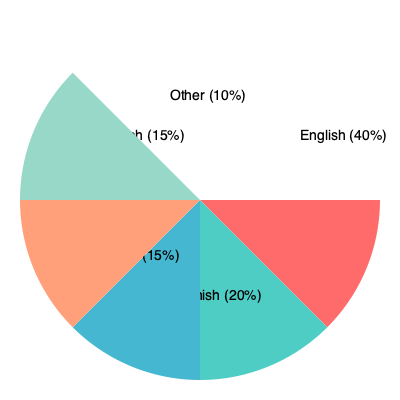Based on the pie chart depicting language use in a multilingual community, what sociolinguistic phenomenon might explain the dominance of English, and how could this impact social stratification? To answer this question, let's analyze the pie chart and consider sociolinguistic concepts:

1. Language distribution:
   - English: 40%
   - Spanish: 20%
   - Mandarin: 15%
   - French: 15%
   - Other: 10%

2. English dominance:
   English clearly dominates at 40%, which is twice the percentage of the next most spoken language (Spanish at 20%).

3. Sociolinguistic phenomenon:
   This distribution suggests linguistic hegemony, where English has become the dominant language in this multilingual community.

4. Factors contributing to linguistic hegemony:
   a) Historical factors (e.g., colonialism, immigration patterns)
   b) Economic factors (e.g., global business language)
   c) Cultural factors (e.g., media influence, education system)

5. Impact on social stratification:
   a) Access to opportunities: Those proficient in English may have better access to education and job opportunities.
   b) Social mobility: English proficiency could become a factor in upward social mobility.
   c) Cultural capital: English skills may be viewed as valuable cultural capital.
   d) Power dynamics: English speakers might have more influence in social and political spheres.

6. Potential consequences:
   a) Language shift: Minority languages might be at risk of decline.
   b) Linguistic inequality: Non-English speakers may face social and economic disadvantages.
   c) Identity negotiation: Individuals may struggle between maintaining heritage languages and adopting English.

The sociolinguistic phenomenon explaining English dominance is likely linguistic hegemony, which could impact social stratification by creating language-based inequalities in access to opportunities, social mobility, and power dynamics.
Answer: Linguistic hegemony 